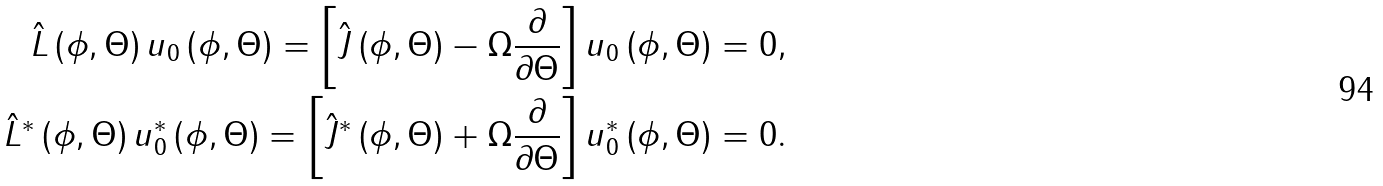Convert formula to latex. <formula><loc_0><loc_0><loc_500><loc_500>\hat { L } \left ( \phi , \Theta \right ) u _ { 0 } \left ( \phi , \Theta \right ) = \left [ \hat { J } \left ( \phi , \Theta \right ) - \Omega \frac { \partial } { \partial \Theta } \right ] u _ { 0 } \left ( \phi , \Theta \right ) & = 0 , \\ \hat { L } ^ { \ast } \left ( \phi , \Theta \right ) u _ { 0 } ^ { \ast } \left ( \phi , \Theta \right ) = \left [ \hat { J } ^ { \ast } \left ( \phi , \Theta \right ) + \Omega \frac { \partial } { \partial \Theta } \right ] u _ { 0 } ^ { \ast } \left ( \phi , \Theta \right ) & = 0 .</formula> 